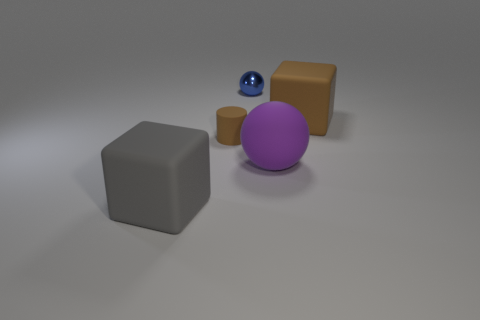Add 4 large rubber cylinders. How many objects exist? 9 Subtract all cubes. How many objects are left? 3 Add 3 large brown objects. How many large brown objects are left? 4 Add 4 cyan metal blocks. How many cyan metal blocks exist? 4 Subtract 0 cyan balls. How many objects are left? 5 Subtract all brown cubes. Subtract all tiny balls. How many objects are left? 3 